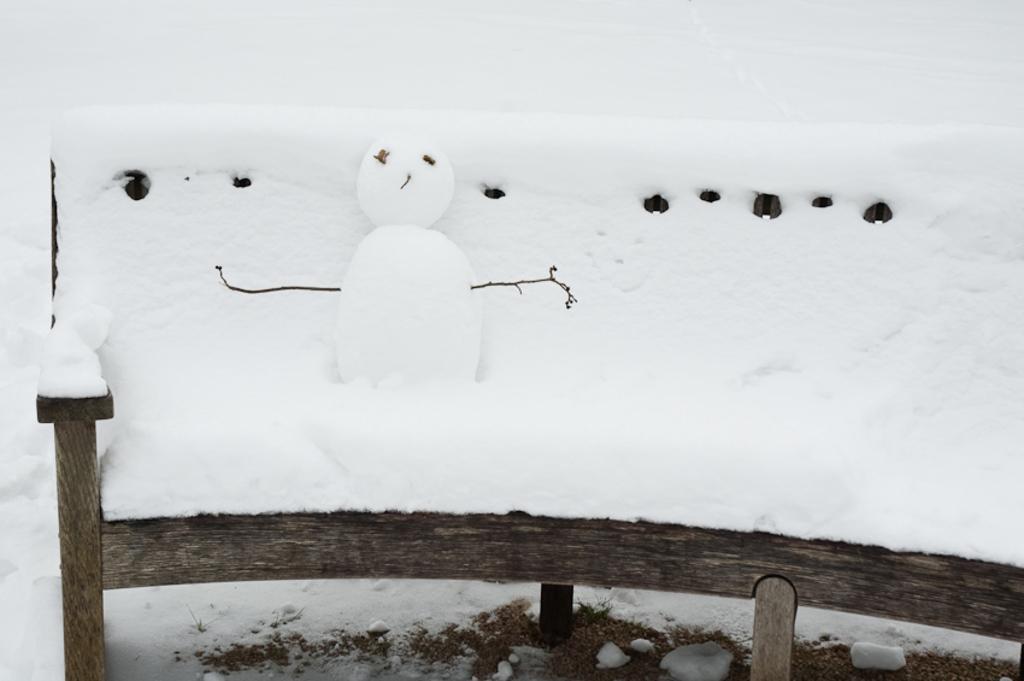In one or two sentences, can you explain what this image depicts? In this picture we can see the snow. We can see the wooden bench is covered with the snow. We can see a snowman and the twigs. At the bottom portion of the picture it seems like the ground. 